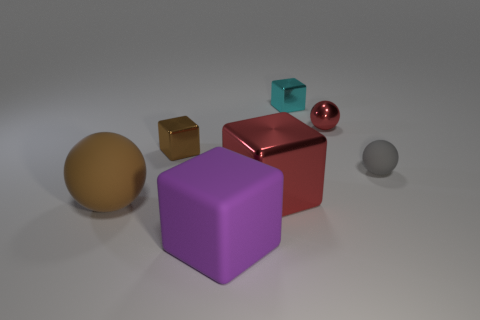What is the material of the large purple object?
Give a very brief answer. Rubber. There is a sphere that is both to the right of the brown rubber thing and in front of the shiny ball; what is its color?
Make the answer very short. Gray. Are there an equal number of red metallic objects in front of the brown block and big red things that are to the right of the tiny rubber sphere?
Ensure brevity in your answer.  No. What is the color of the other big object that is the same material as the purple thing?
Your response must be concise. Brown. Is the color of the rubber block the same as the object right of the red metallic ball?
Offer a terse response. No. Is there a red metal cube right of the small block behind the red object behind the small gray object?
Offer a terse response. No. There is a tiny red thing that is the same material as the cyan block; what shape is it?
Ensure brevity in your answer.  Sphere. Is there anything else that is the same shape as the brown rubber object?
Your response must be concise. Yes. The tiny red shiny thing is what shape?
Keep it short and to the point. Sphere. Is the shape of the big red shiny object that is left of the small matte ball the same as  the tiny gray matte object?
Offer a very short reply. No. 